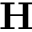<formula> <loc_0><loc_0><loc_500><loc_500>H</formula> 